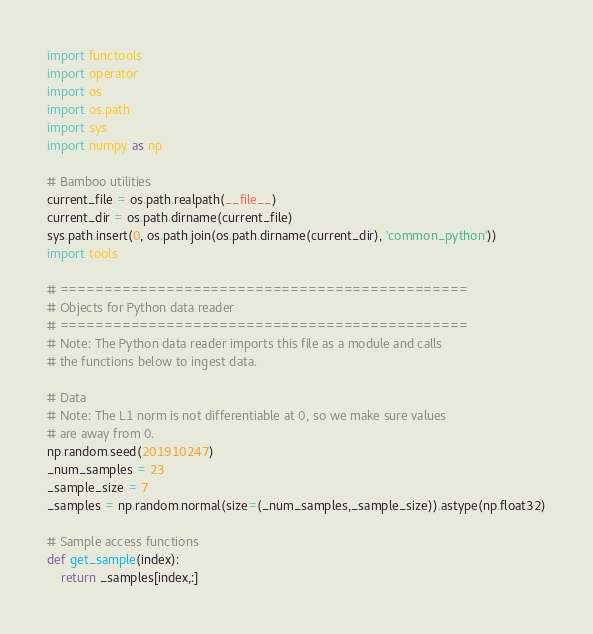Convert code to text. <code><loc_0><loc_0><loc_500><loc_500><_Python_>import functools
import operator
import os
import os.path
import sys
import numpy as np

# Bamboo utilities
current_file = os.path.realpath(__file__)
current_dir = os.path.dirname(current_file)
sys.path.insert(0, os.path.join(os.path.dirname(current_dir), 'common_python'))
import tools

# ==============================================
# Objects for Python data reader
# ==============================================
# Note: The Python data reader imports this file as a module and calls
# the functions below to ingest data.

# Data
# Note: The L1 norm is not differentiable at 0, so we make sure values
# are away from 0.
np.random.seed(201910247)
_num_samples = 23
_sample_size = 7
_samples = np.random.normal(size=(_num_samples,_sample_size)).astype(np.float32)

# Sample access functions
def get_sample(index):
    return _samples[index,:]</code> 